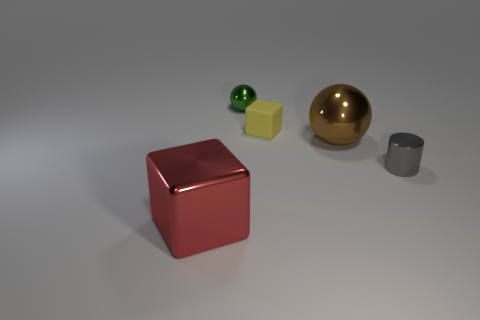Is there any other thing that is made of the same material as the tiny yellow thing?
Your answer should be very brief. No. What color is the large metal block?
Make the answer very short. Red. Does the large thing that is behind the big metallic block have the same material as the object that is on the right side of the brown ball?
Your response must be concise. Yes. There is a large thing that is the same shape as the small green object; what is its material?
Ensure brevity in your answer.  Metal. Are the tiny cylinder and the green sphere made of the same material?
Your answer should be very brief. Yes. There is a cube right of the cube in front of the tiny yellow block; what color is it?
Your answer should be compact. Yellow. There is a gray cylinder that is the same material as the big red cube; what is its size?
Ensure brevity in your answer.  Small. What number of big red objects have the same shape as the large brown object?
Offer a very short reply. 0. What number of objects are things that are right of the rubber block or things to the left of the green shiny ball?
Offer a terse response. 3. What number of gray cylinders are in front of the tiny metallic object that is behind the brown object?
Your response must be concise. 1. 